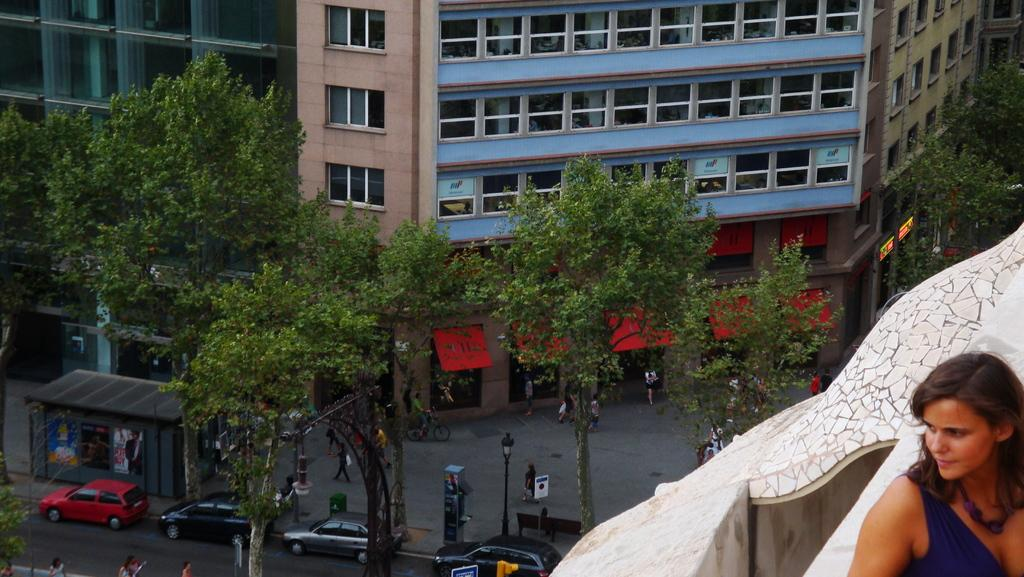What type of natural elements can be seen in the image? There are trees in the image. What man-made objects are present in the image? There are vehicles and buildings in the image. Can you describe the people in the image? There is a group of people in the image. What can be seen in the background of the image? There are poles, lights, and sign boards in the background of the image. What type of cookware is visible in the image? There is no cookware present in the image. How many people are walking in the image? There is no indication of anyone walking in the image; it only shows a group of people standing. Can you describe the contents of the drawer in the image? There is no drawer present in the image. 